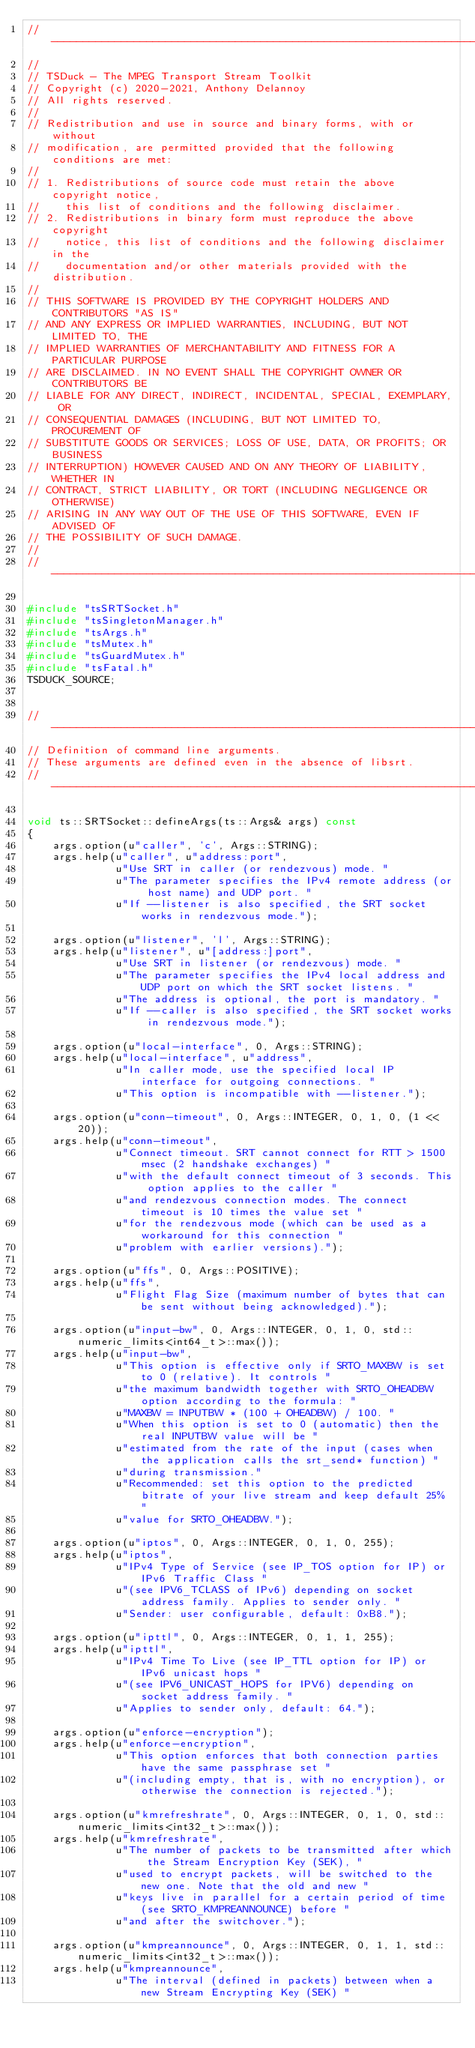Convert code to text. <code><loc_0><loc_0><loc_500><loc_500><_C++_>//----------------------------------------------------------------------------
//
// TSDuck - The MPEG Transport Stream Toolkit
// Copyright (c) 2020-2021, Anthony Delannoy
// All rights reserved.
//
// Redistribution and use in source and binary forms, with or without
// modification, are permitted provided that the following conditions are met:
//
// 1. Redistributions of source code must retain the above copyright notice,
//    this list of conditions and the following disclaimer.
// 2. Redistributions in binary form must reproduce the above copyright
//    notice, this list of conditions and the following disclaimer in the
//    documentation and/or other materials provided with the distribution.
//
// THIS SOFTWARE IS PROVIDED BY THE COPYRIGHT HOLDERS AND CONTRIBUTORS "AS IS"
// AND ANY EXPRESS OR IMPLIED WARRANTIES, INCLUDING, BUT NOT LIMITED TO, THE
// IMPLIED WARRANTIES OF MERCHANTABILITY AND FITNESS FOR A PARTICULAR PURPOSE
// ARE DISCLAIMED. IN NO EVENT SHALL THE COPYRIGHT OWNER OR CONTRIBUTORS BE
// LIABLE FOR ANY DIRECT, INDIRECT, INCIDENTAL, SPECIAL, EXEMPLARY, OR
// CONSEQUENTIAL DAMAGES (INCLUDING, BUT NOT LIMITED TO, PROCUREMENT OF
// SUBSTITUTE GOODS OR SERVICES; LOSS OF USE, DATA, OR PROFITS; OR BUSINESS
// INTERRUPTION) HOWEVER CAUSED AND ON ANY THEORY OF LIABILITY, WHETHER IN
// CONTRACT, STRICT LIABILITY, OR TORT (INCLUDING NEGLIGENCE OR OTHERWISE)
// ARISING IN ANY WAY OUT OF THE USE OF THIS SOFTWARE, EVEN IF ADVISED OF
// THE POSSIBILITY OF SUCH DAMAGE.
//
//----------------------------------------------------------------------------

#include "tsSRTSocket.h"
#include "tsSingletonManager.h"
#include "tsArgs.h"
#include "tsMutex.h"
#include "tsGuardMutex.h"
#include "tsFatal.h"
TSDUCK_SOURCE;


//----------------------------------------------------------------------------
// Definition of command line arguments.
// These arguments are defined even in the absence of libsrt.
//----------------------------------------------------------------------------

void ts::SRTSocket::defineArgs(ts::Args& args) const
{
    args.option(u"caller", 'c', Args::STRING);
    args.help(u"caller", u"address:port",
              u"Use SRT in caller (or rendezvous) mode. "
              u"The parameter specifies the IPv4 remote address (or host name) and UDP port. "
              u"If --listener is also specified, the SRT socket works in rendezvous mode.");

    args.option(u"listener", 'l', Args::STRING);
    args.help(u"listener", u"[address:]port",
              u"Use SRT in listener (or rendezvous) mode. "
              u"The parameter specifies the IPv4 local address and UDP port on which the SRT socket listens. "
              u"The address is optional, the port is mandatory. "
              u"If --caller is also specified, the SRT socket works in rendezvous mode.");

    args.option(u"local-interface", 0, Args::STRING);
    args.help(u"local-interface", u"address",
              u"In caller mode, use the specified local IP interface for outgoing connections. "
              u"This option is incompatible with --listener.");

    args.option(u"conn-timeout", 0, Args::INTEGER, 0, 1, 0, (1 << 20));
    args.help(u"conn-timeout",
              u"Connect timeout. SRT cannot connect for RTT > 1500 msec (2 handshake exchanges) "
              u"with the default connect timeout of 3 seconds. This option applies to the caller "
              u"and rendezvous connection modes. The connect timeout is 10 times the value set "
              u"for the rendezvous mode (which can be used as a workaround for this connection "
              u"problem with earlier versions).");

    args.option(u"ffs", 0, Args::POSITIVE);
    args.help(u"ffs",
              u"Flight Flag Size (maximum number of bytes that can be sent without being acknowledged).");

    args.option(u"input-bw", 0, Args::INTEGER, 0, 1, 0, std::numeric_limits<int64_t>::max());
    args.help(u"input-bw",
              u"This option is effective only if SRTO_MAXBW is set to 0 (relative). It controls "
              u"the maximum bandwidth together with SRTO_OHEADBW option according to the formula: "
              u"MAXBW = INPUTBW * (100 + OHEADBW) / 100. "
              u"When this option is set to 0 (automatic) then the real INPUTBW value will be "
              u"estimated from the rate of the input (cases when the application calls the srt_send* function) "
              u"during transmission."
              u"Recommended: set this option to the predicted bitrate of your live stream and keep default 25% "
              u"value for SRTO_OHEADBW.");

    args.option(u"iptos", 0, Args::INTEGER, 0, 1, 0, 255);
    args.help(u"iptos",
              u"IPv4 Type of Service (see IP_TOS option for IP) or IPv6 Traffic Class "
              u"(see IPV6_TCLASS of IPv6) depending on socket address family. Applies to sender only. "
              u"Sender: user configurable, default: 0xB8.");

    args.option(u"ipttl", 0, Args::INTEGER, 0, 1, 1, 255);
    args.help(u"ipttl",
              u"IPv4 Time To Live (see IP_TTL option for IP) or IPv6 unicast hops "
              u"(see IPV6_UNICAST_HOPS for IPV6) depending on socket address family. "
              u"Applies to sender only, default: 64.");

    args.option(u"enforce-encryption");
    args.help(u"enforce-encryption",
              u"This option enforces that both connection parties have the same passphrase set "
              u"(including empty, that is, with no encryption), or otherwise the connection is rejected.");

    args.option(u"kmrefreshrate", 0, Args::INTEGER, 0, 1, 0, std::numeric_limits<int32_t>::max());
    args.help(u"kmrefreshrate",
              u"The number of packets to be transmitted after which the Stream Encryption Key (SEK), "
              u"used to encrypt packets, will be switched to the new one. Note that the old and new "
              u"keys live in parallel for a certain period of time (see SRTO_KMPREANNOUNCE) before "
              u"and after the switchover.");

    args.option(u"kmpreannounce", 0, Args::INTEGER, 0, 1, 1, std::numeric_limits<int32_t>::max());
    args.help(u"kmpreannounce",
              u"The interval (defined in packets) between when a new Stream Encrypting Key (SEK) "</code> 